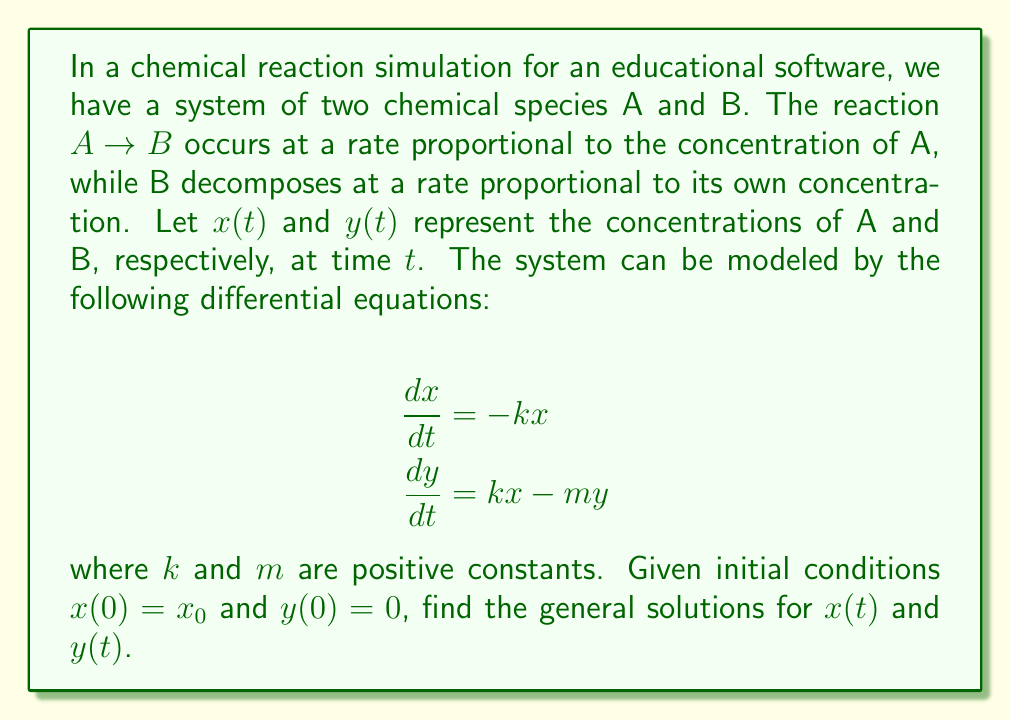Could you help me with this problem? To solve this system of differential equations, we'll follow these steps:

1) First, let's solve for $x(t)$:
   The equation $\frac{dx}{dt} = -kx$ is a separable first-order differential equation.
   
   Separating variables: $\frac{dx}{x} = -k dt$
   
   Integrating both sides: $\ln|x| = -kt + C$
   
   Exponentiating: $x(t) = Ce^{-kt}$
   
   Using the initial condition $x(0) = x_0$, we get $C = x_0$
   
   Therefore, $x(t) = x_0e^{-kt}$

2) Now, let's solve for $y(t)$:
   Substituting $x(t)$ into the equation for $y$:
   
   $\frac{dy}{dt} = kx_0e^{-kt} - my$
   
   This is a first-order linear differential equation of the form $\frac{dy}{dt} + my = kx_0e^{-kt}$
   
   The integrating factor is $e^{mt}$
   
   Multiplying both sides by $e^{mt}$:
   
   $e^{mt}\frac{dy}{dt} + me^{mt}y = kx_0e^{(m-k)t}$
   
   The left side is now the derivative of $e^{mt}y$:
   
   $\frac{d}{dt}(e^{mt}y) = kx_0e^{(m-k)t}$
   
   Integrating both sides:
   
   $e^{mt}y = \frac{kx_0}{m-k}e^{(m-k)t} + C$
   
   Dividing by $e^{mt}$:
   
   $y(t) = \frac{kx_0}{m-k}e^{-kt} + Ce^{-mt}$
   
   Using the initial condition $y(0) = 0$:
   
   $0 = \frac{kx_0}{m-k} + C$
   
   $C = -\frac{kx_0}{m-k}$
   
   Therefore, $y(t) = \frac{kx_0}{m-k}(e^{-kt} - e^{-mt})$

Thus, we have found the general solutions for both $x(t)$ and $y(t)$.
Answer: $x(t) = x_0e^{-kt}$
$y(t) = \frac{kx_0}{m-k}(e^{-kt} - e^{-mt})$ 